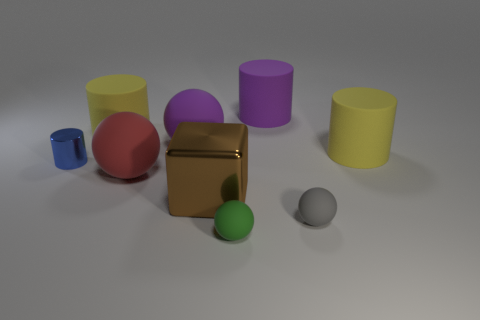What is the color of the tiny cylinder? The tiny cylinder in the image is blue. It's the smallest object in the group, located towards the front left, providing a nice contrast to the larger, more brightly colored objects in the background. 